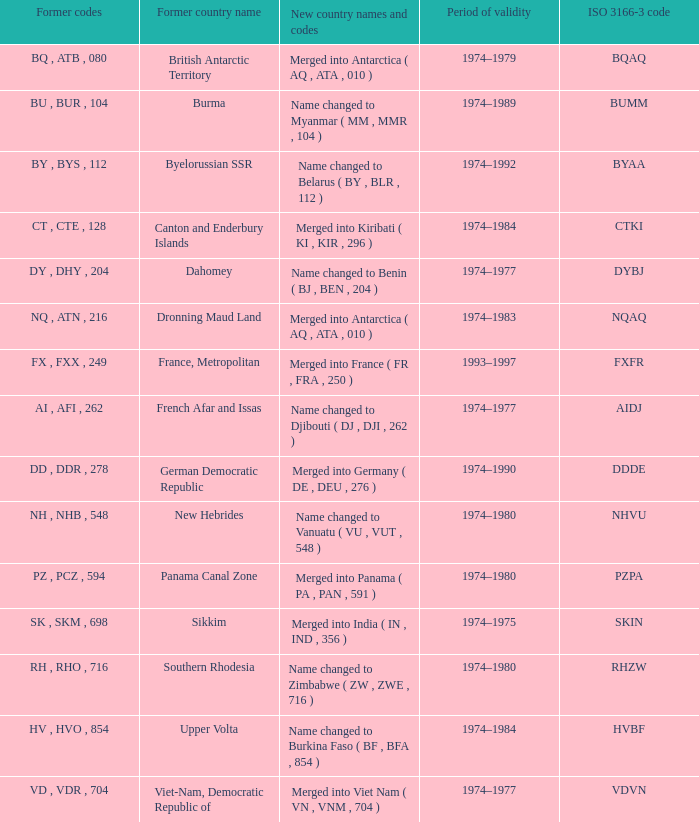Name the total number for period of validity for upper volta 1.0. 